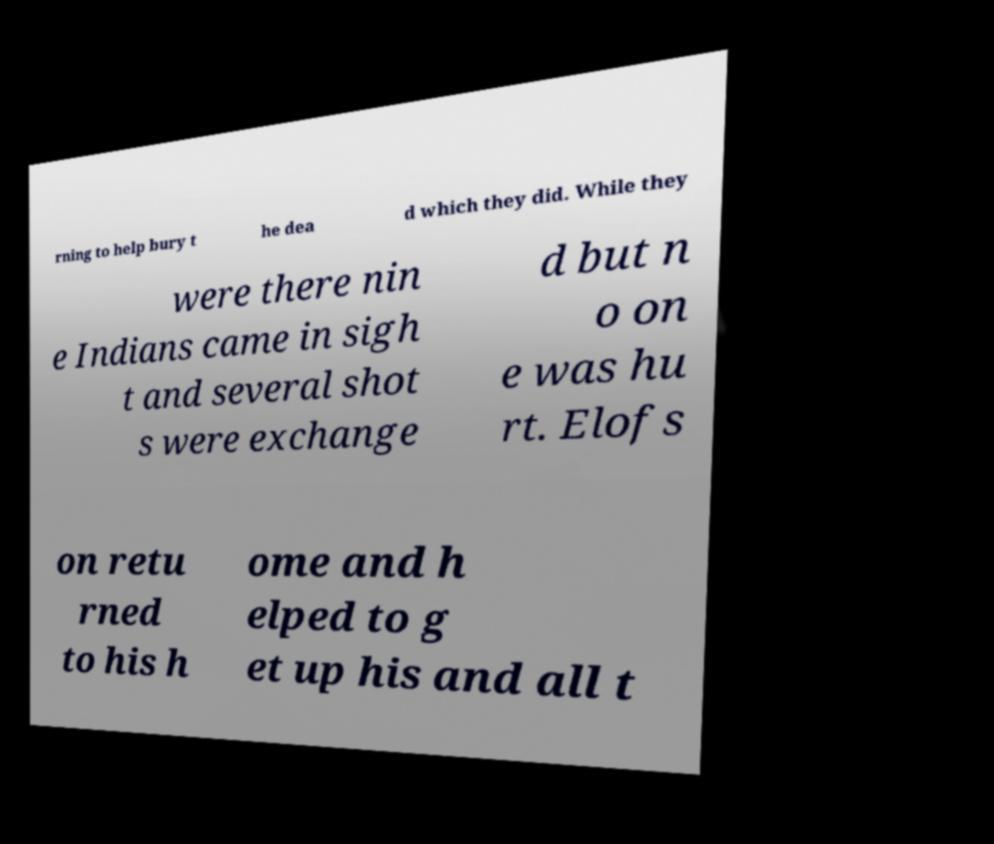Could you assist in decoding the text presented in this image and type it out clearly? rning to help bury t he dea d which they did. While they were there nin e Indians came in sigh t and several shot s were exchange d but n o on e was hu rt. Elofs on retu rned to his h ome and h elped to g et up his and all t 